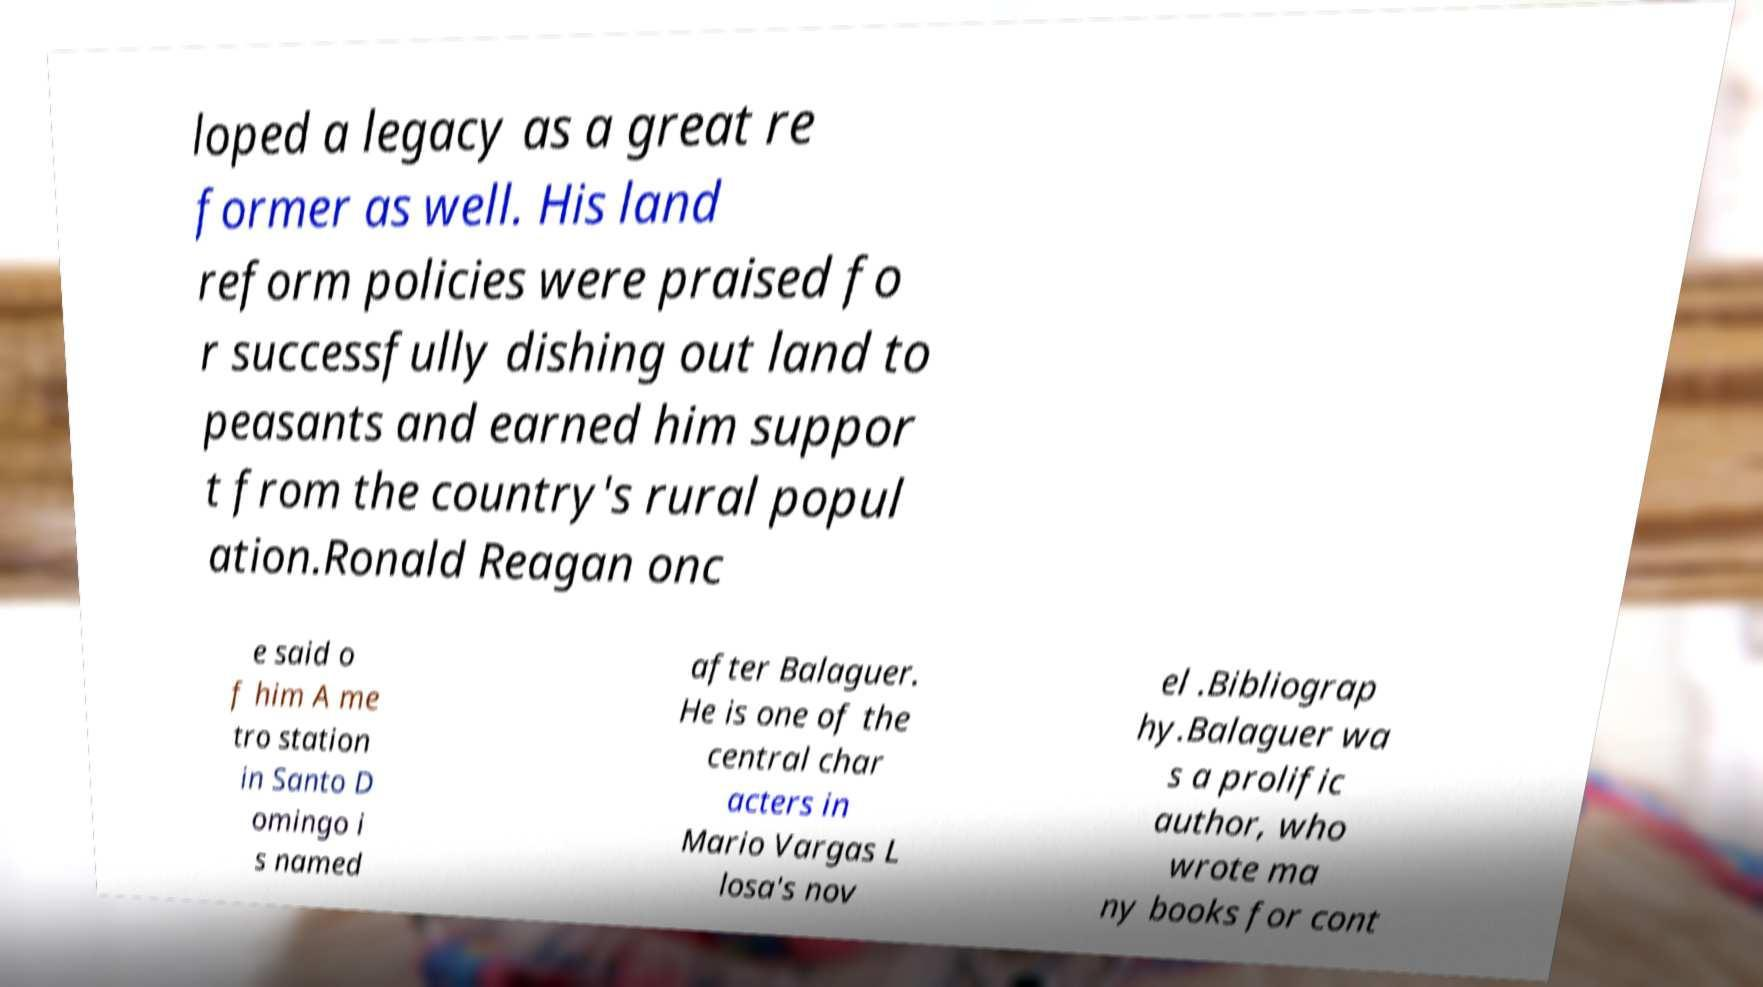Can you read and provide the text displayed in the image?This photo seems to have some interesting text. Can you extract and type it out for me? loped a legacy as a great re former as well. His land reform policies were praised fo r successfully dishing out land to peasants and earned him suppor t from the country's rural popul ation.Ronald Reagan onc e said o f him A me tro station in Santo D omingo i s named after Balaguer. He is one of the central char acters in Mario Vargas L losa's nov el .Bibliograp hy.Balaguer wa s a prolific author, who wrote ma ny books for cont 